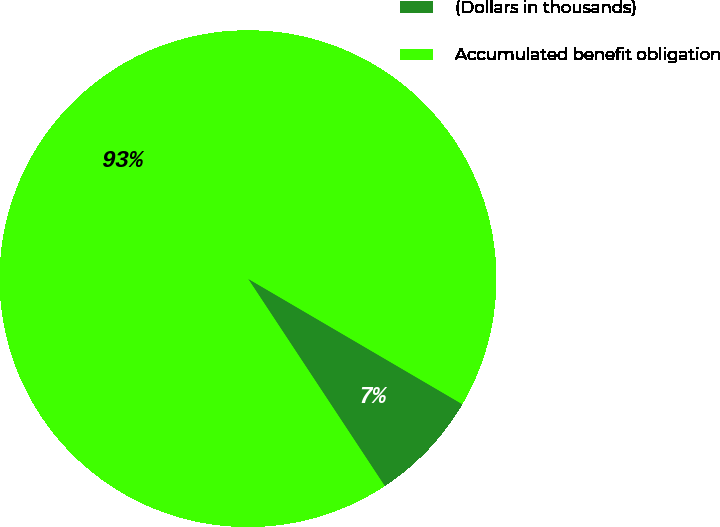Convert chart to OTSL. <chart><loc_0><loc_0><loc_500><loc_500><pie_chart><fcel>(Dollars in thousands)<fcel>Accumulated benefit obligation<nl><fcel>7.29%<fcel>92.71%<nl></chart> 